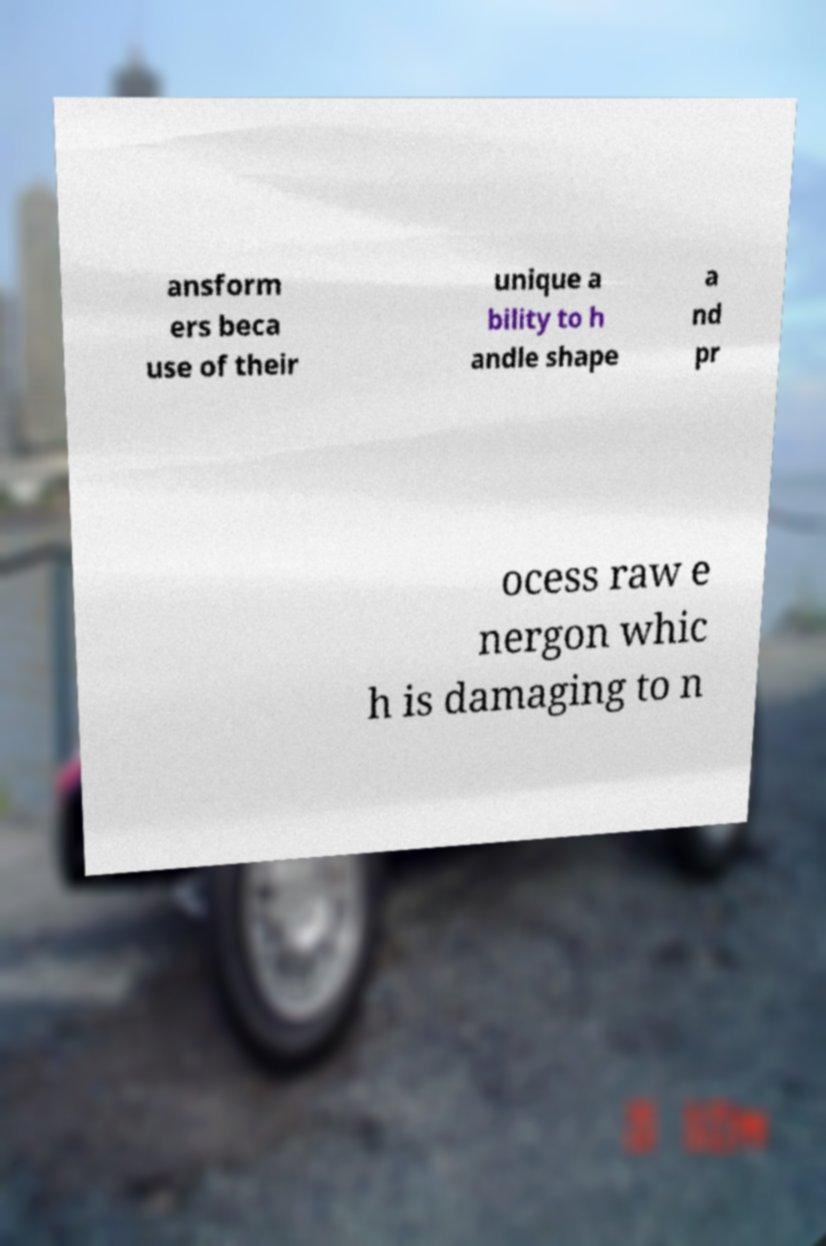Please identify and transcribe the text found in this image. ansform ers beca use of their unique a bility to h andle shape a nd pr ocess raw e nergon whic h is damaging to n 